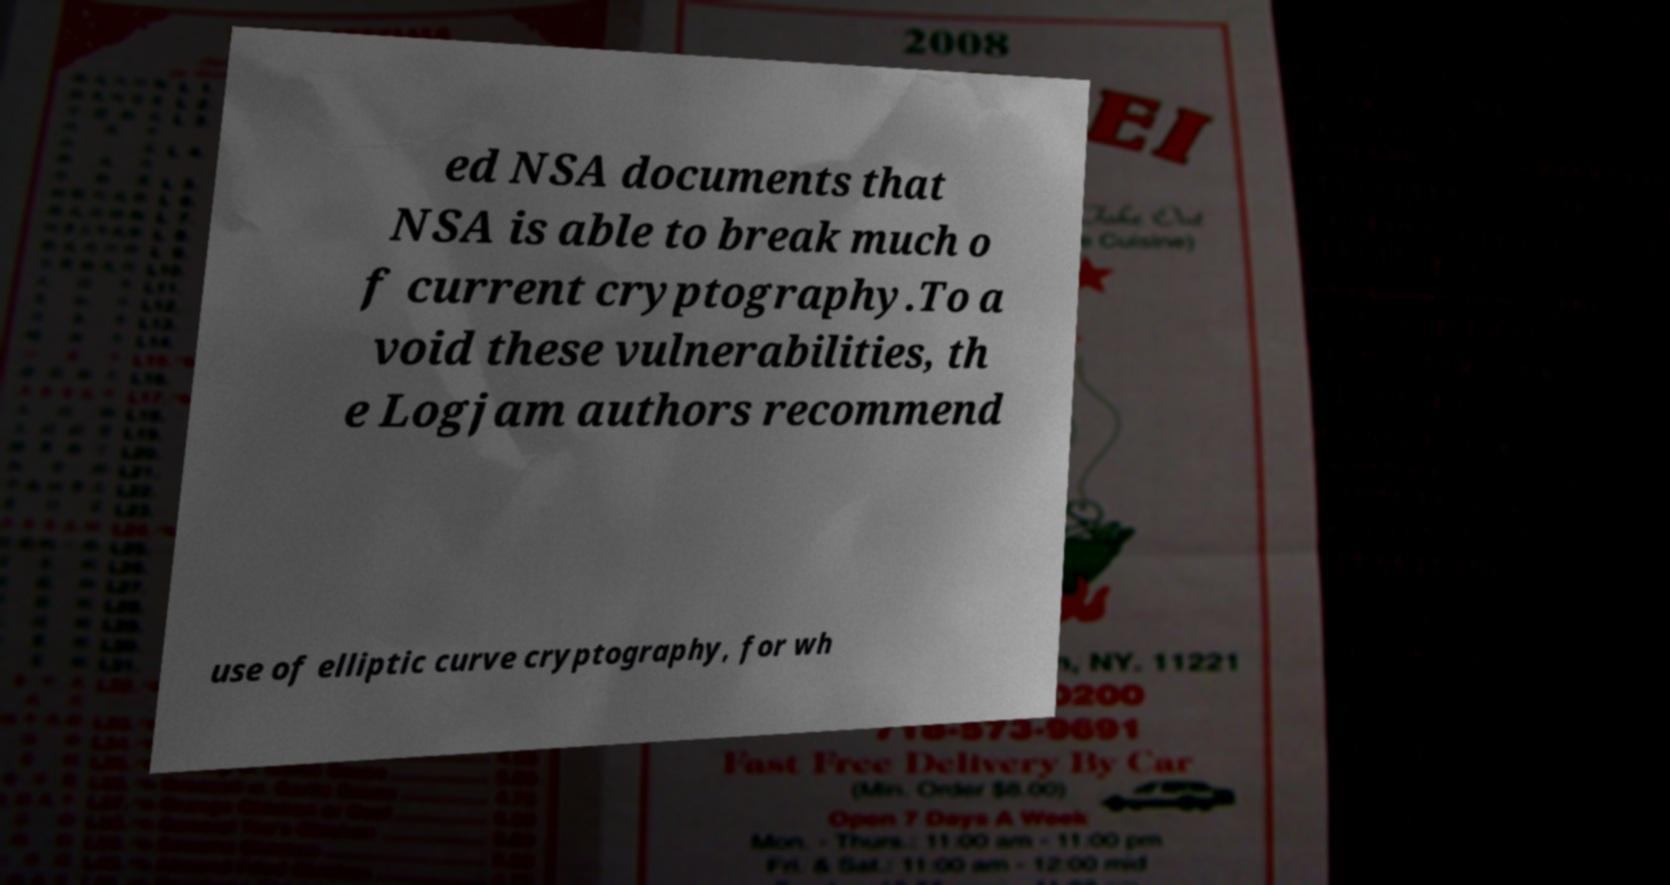Can you accurately transcribe the text from the provided image for me? ed NSA documents that NSA is able to break much o f current cryptography.To a void these vulnerabilities, th e Logjam authors recommend use of elliptic curve cryptography, for wh 